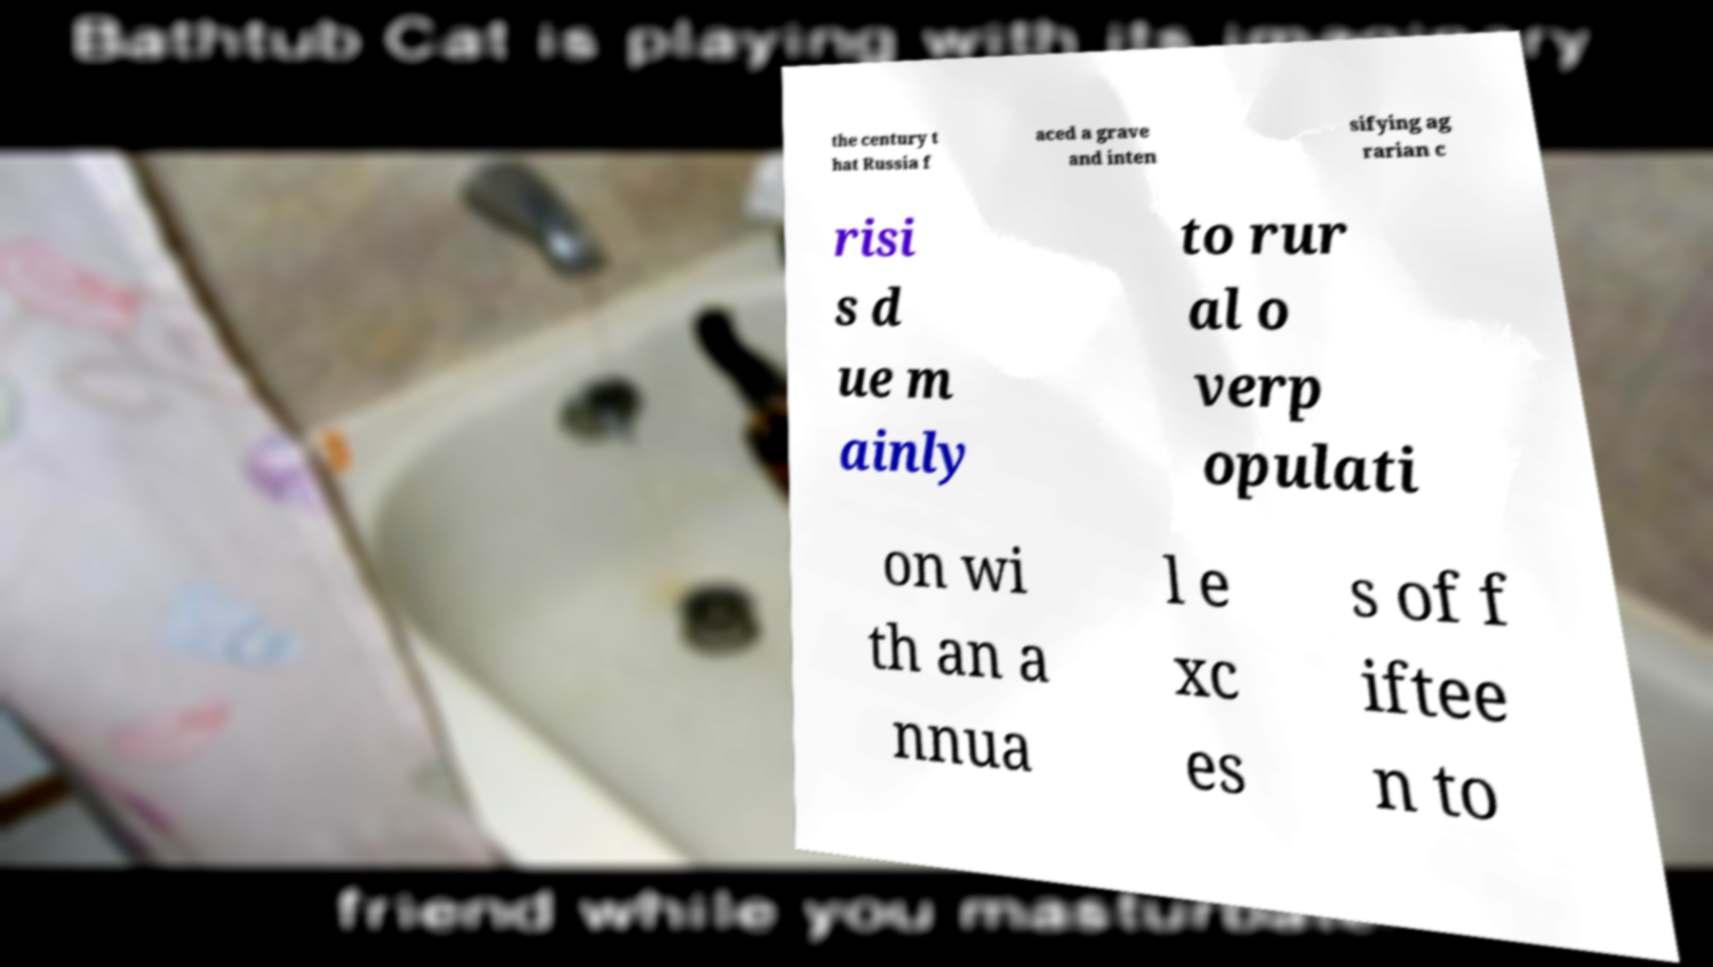What messages or text are displayed in this image? I need them in a readable, typed format. the century t hat Russia f aced a grave and inten sifying ag rarian c risi s d ue m ainly to rur al o verp opulati on wi th an a nnua l e xc es s of f iftee n to 